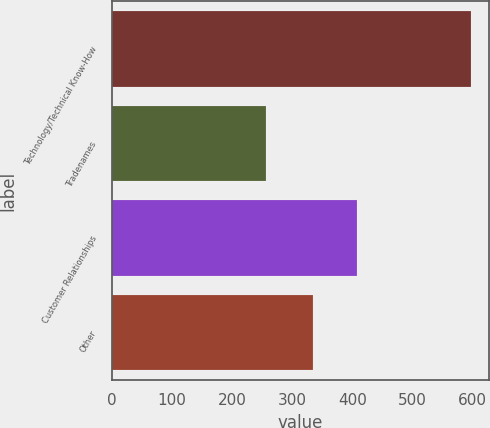Convert chart to OTSL. <chart><loc_0><loc_0><loc_500><loc_500><bar_chart><fcel>Technology/Technical Know-How<fcel>Tradenames<fcel>Customer Relationships<fcel>Other<nl><fcel>597<fcel>257<fcel>407<fcel>335<nl></chart> 